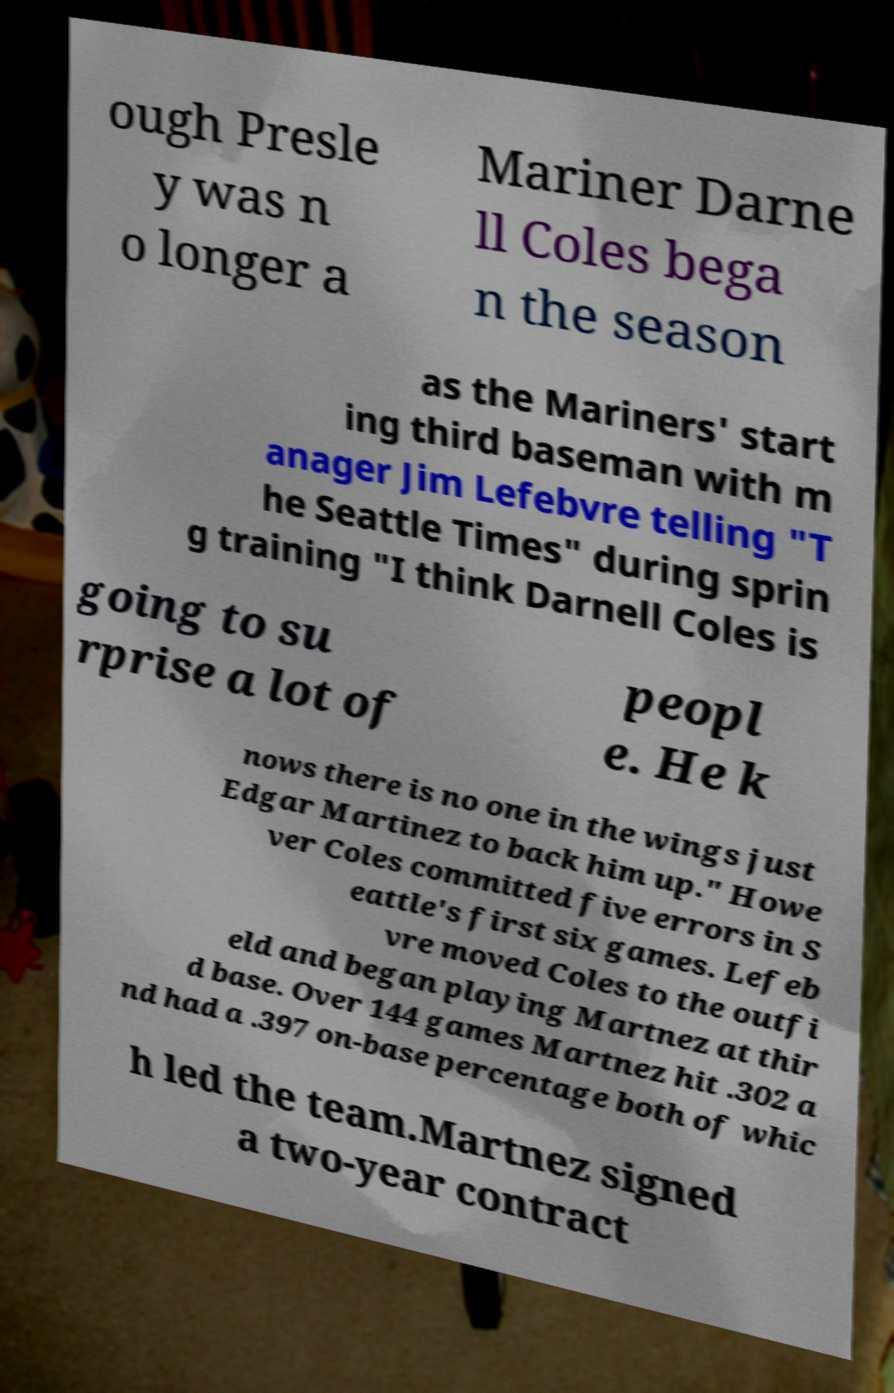For documentation purposes, I need the text within this image transcribed. Could you provide that? ough Presle y was n o longer a Mariner Darne ll Coles bega n the season as the Mariners' start ing third baseman with m anager Jim Lefebvre telling "T he Seattle Times" during sprin g training "I think Darnell Coles is going to su rprise a lot of peopl e. He k nows there is no one in the wings just Edgar Martinez to back him up." Howe ver Coles committed five errors in S eattle's first six games. Lefeb vre moved Coles to the outfi eld and began playing Martnez at thir d base. Over 144 games Martnez hit .302 a nd had a .397 on-base percentage both of whic h led the team.Martnez signed a two-year contract 